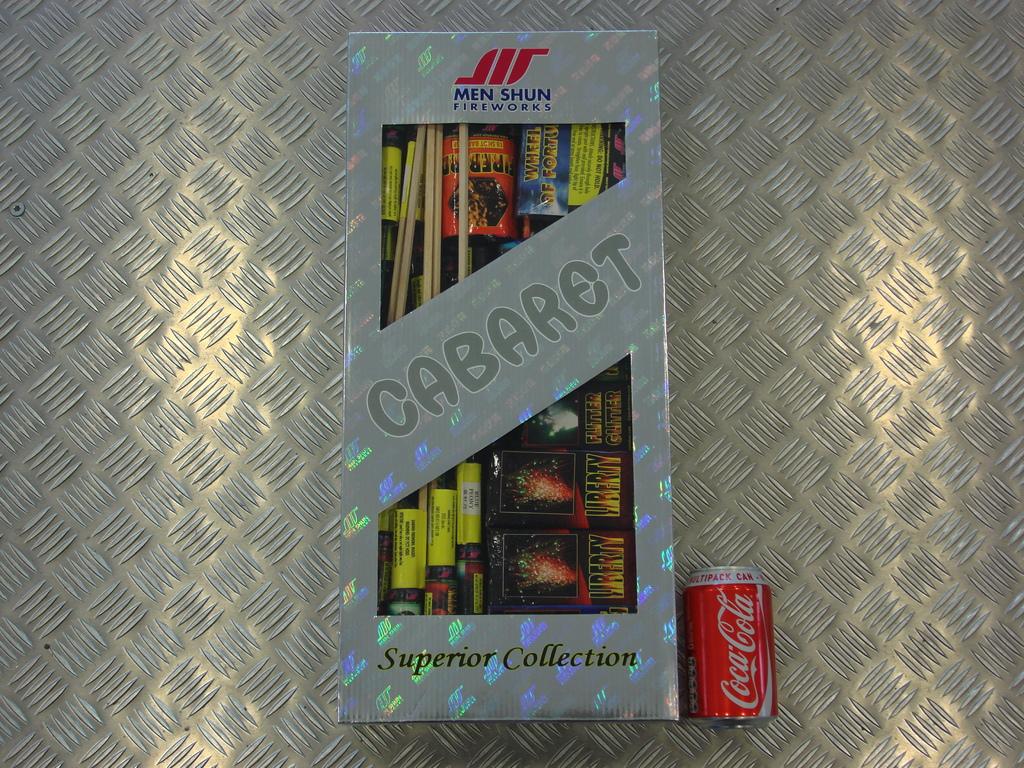What drink is beside the box?
Give a very brief answer. Coca-cola. What brand of fireworks is on the box?
Your response must be concise. Cabaret. 